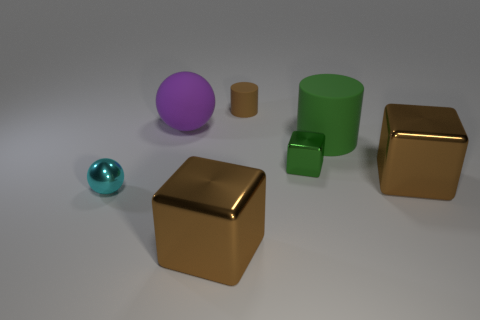Is there any other thing that has the same color as the tiny metal cube?
Provide a short and direct response. Yes. Is the material of the brown cube that is on the left side of the tiny brown thing the same as the cube that is on the right side of the small green cube?
Your answer should be compact. Yes. There is a matte ball; how many small metallic balls are to the left of it?
Ensure brevity in your answer.  1. How many purple objects are large spheres or metallic cylinders?
Your answer should be compact. 1. There is a green object that is the same size as the purple matte object; what is its material?
Keep it short and to the point. Rubber. The tiny thing that is both on the right side of the large ball and in front of the big purple rubber object has what shape?
Offer a terse response. Cube. There is a shiny ball that is the same size as the green metallic block; what is its color?
Keep it short and to the point. Cyan. Does the brown cube to the right of the small green thing have the same size as the green metallic cube that is right of the brown rubber cylinder?
Ensure brevity in your answer.  No. There is a matte thing that is to the right of the metal thing that is behind the brown shiny block on the right side of the large green thing; how big is it?
Ensure brevity in your answer.  Large. The small metallic object to the right of the large shiny cube to the left of the green metallic block is what shape?
Your answer should be very brief. Cube. 